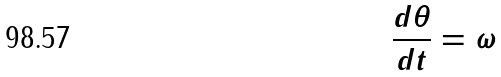<formula> <loc_0><loc_0><loc_500><loc_500>\frac { d \theta } { d t } = \omega</formula> 